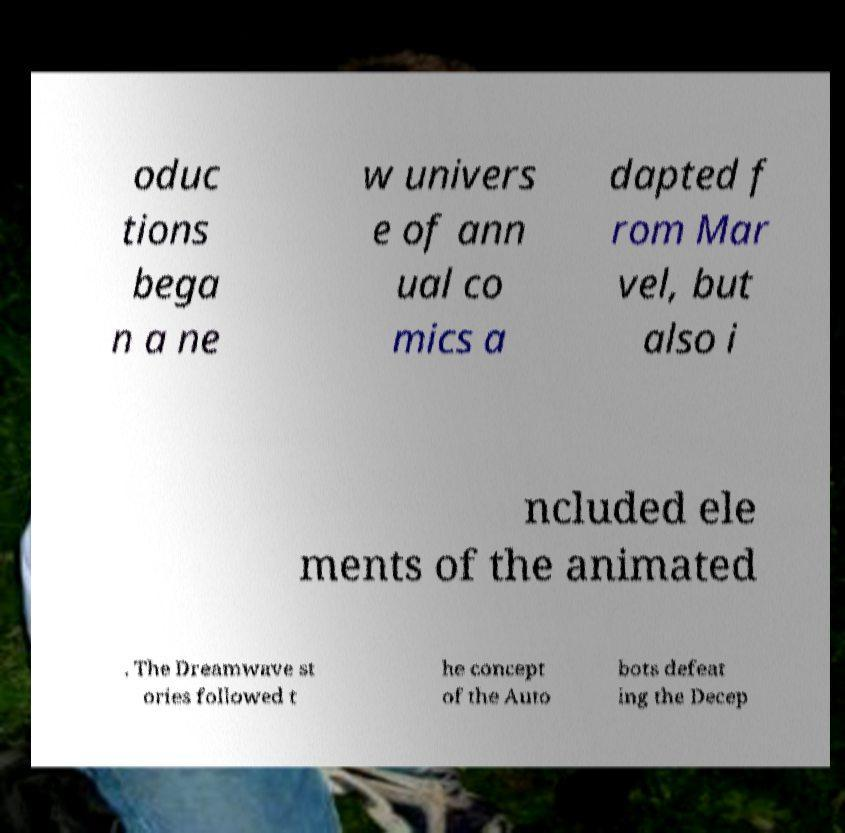Could you extract and type out the text from this image? oduc tions bega n a ne w univers e of ann ual co mics a dapted f rom Mar vel, but also i ncluded ele ments of the animated . The Dreamwave st ories followed t he concept of the Auto bots defeat ing the Decep 